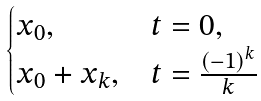Convert formula to latex. <formula><loc_0><loc_0><loc_500><loc_500>\begin{cases} x _ { 0 } , & t = 0 , \\ x _ { 0 } + x _ { k } , & t = \frac { ( - 1 ) ^ { k } } { k } \end{cases}</formula> 